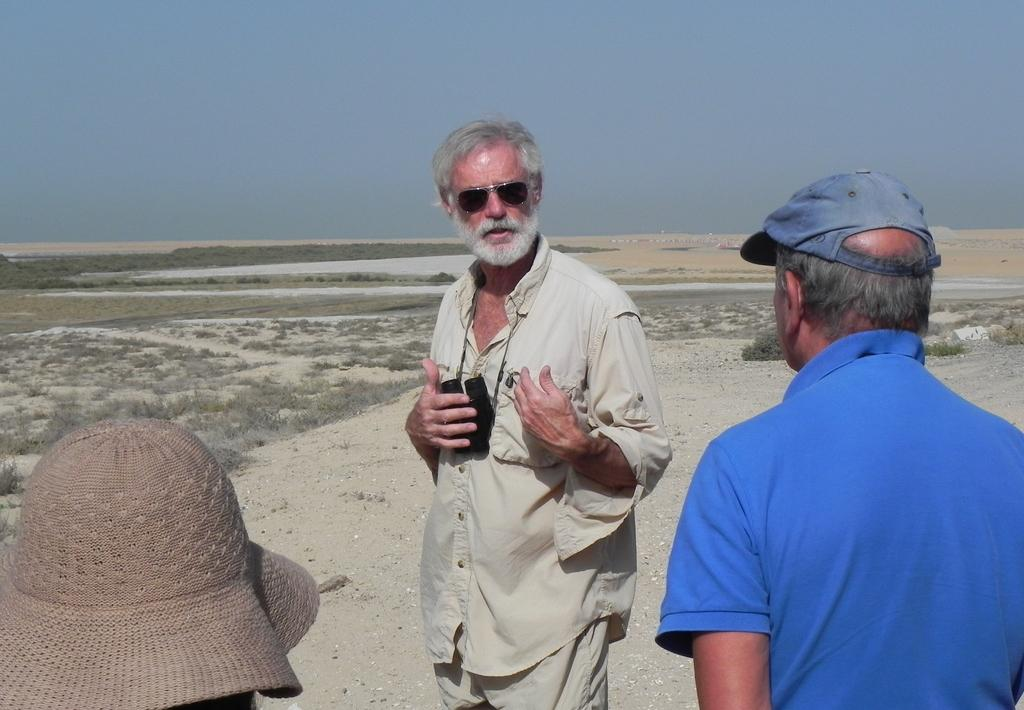Who or what can be seen in the image? There are people in the image. What is the surface that the people are standing on? The ground is visible in the image. What type of vegetation is present in the image? There are dry plants in the image. What is visible above the people and plants? The sky is visible in the image. What type of fang can be seen in the image? There is no fang present in the image. What type of suit is the person wearing in the image? There is no person wearing a suit in the image. 